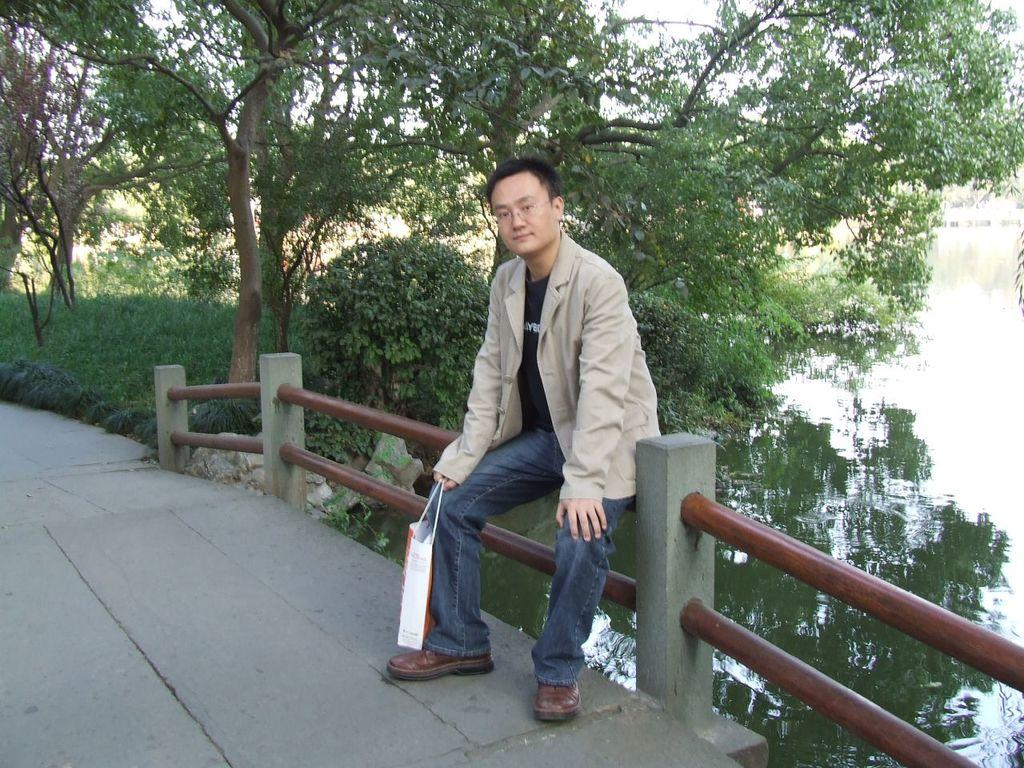What structure is located at the bottom of the image? There is a bridge at the bottom of the image. What feature can be seen on the bridge? There is fencing on the bridge. What is the man in the image doing? The man is sitting on the fencing. What is the man's facial expression? The man is smiling. What is visible behind the man? There is water and trees visible behind the man. What type of needle is the man using to sew a night pie in the image? There is no needle or pie present in the image. The man is sitting on a bridge, smiling, and there is no indication of sewing or pie-making activities. 